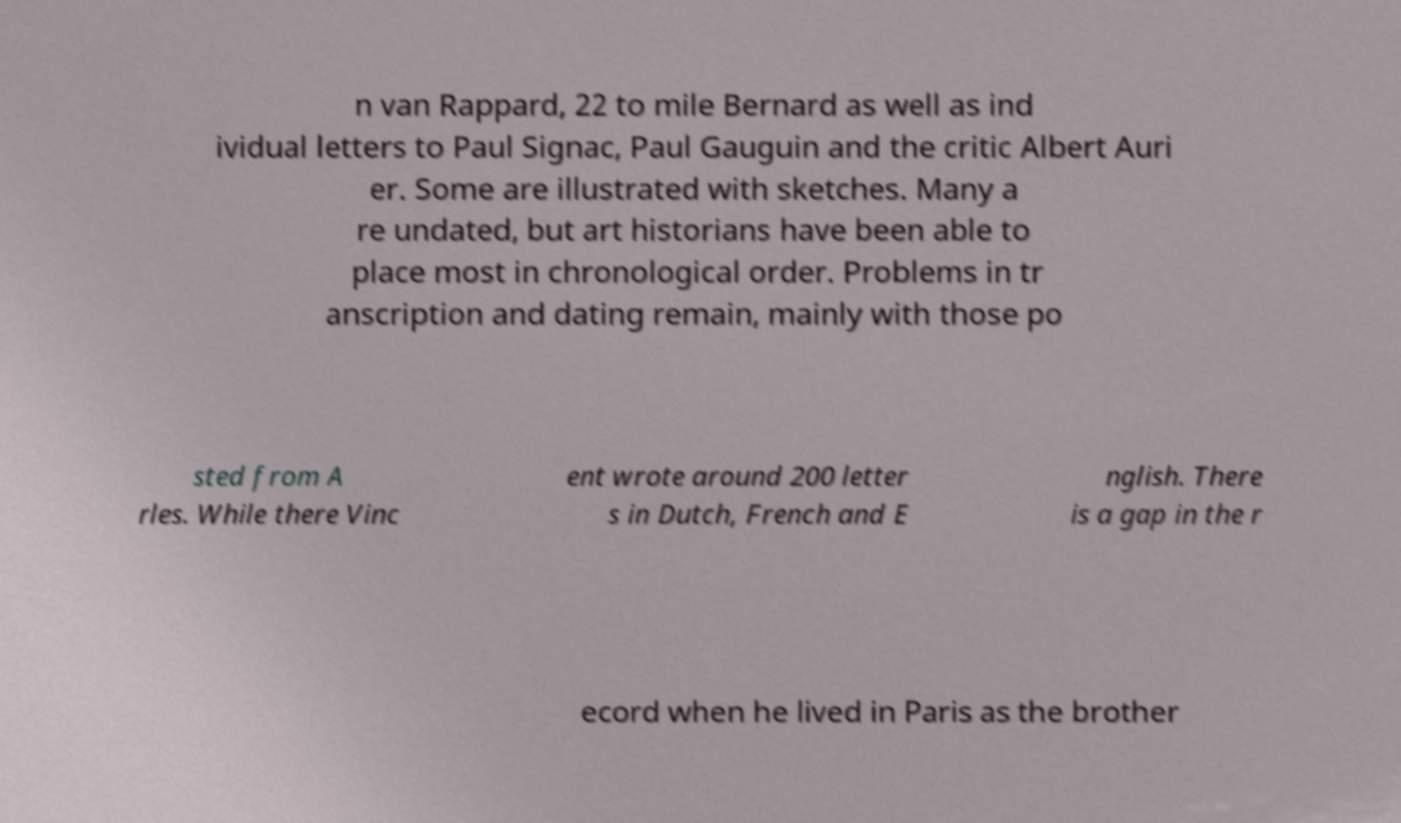Can you accurately transcribe the text from the provided image for me? n van Rappard, 22 to mile Bernard as well as ind ividual letters to Paul Signac, Paul Gauguin and the critic Albert Auri er. Some are illustrated with sketches. Many a re undated, but art historians have been able to place most in chronological order. Problems in tr anscription and dating remain, mainly with those po sted from A rles. While there Vinc ent wrote around 200 letter s in Dutch, French and E nglish. There is a gap in the r ecord when he lived in Paris as the brother 